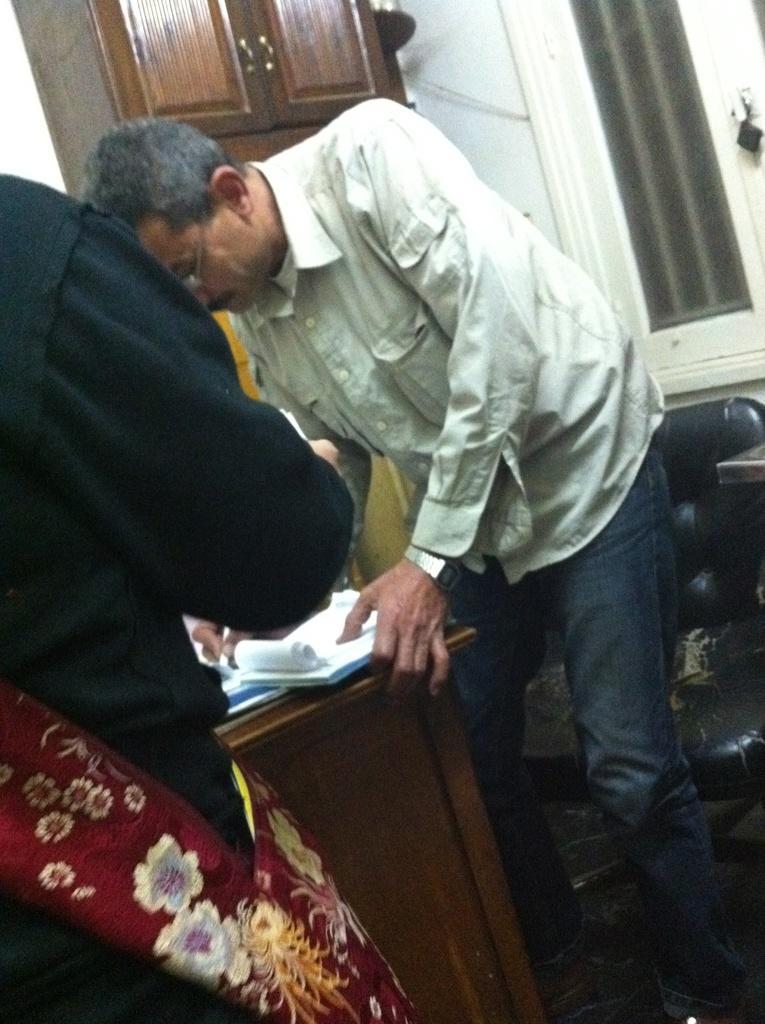Please provide a concise description of this image. In the image there is a man in white shirt leaning on table and signing on paper and a man in black shirt standing on the left side, in the back there are doors on the wall. 